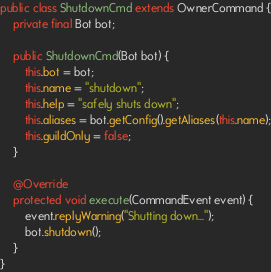<code> <loc_0><loc_0><loc_500><loc_500><_Java_>public class ShutdownCmd extends OwnerCommand {
    private final Bot bot;

    public ShutdownCmd(Bot bot) {
        this.bot = bot;
        this.name = "shutdown";
        this.help = "safely shuts down";
        this.aliases = bot.getConfig().getAliases(this.name);
        this.guildOnly = false;
    }

    @Override
    protected void execute(CommandEvent event) {
        event.replyWarning("Shutting down...");
        bot.shutdown();
    }
}
</code> 